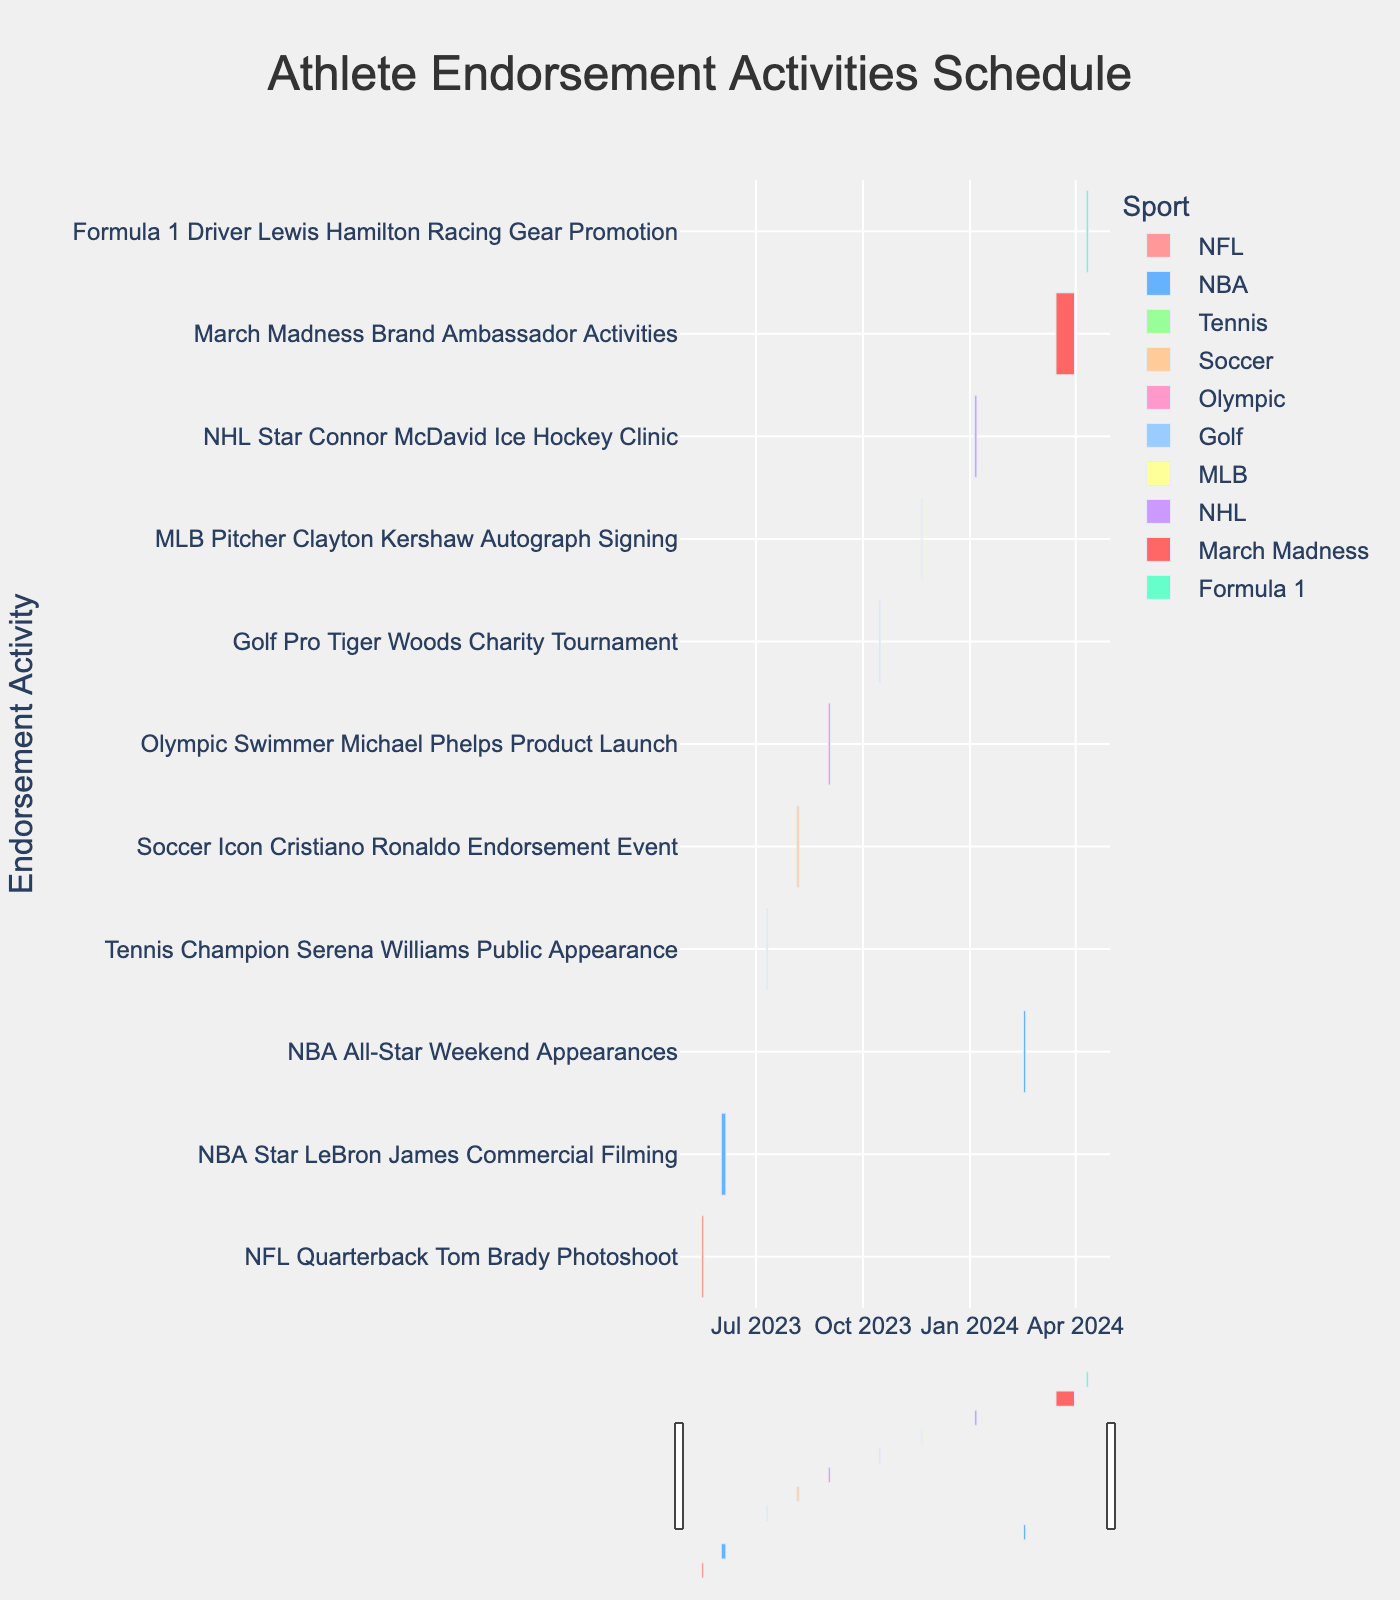Which athlete has the earliest scheduled endorsement activity? The NFL Quarterback Tom Brady's Photoshoot is scheduled from May 15, 2023, to May 17, 2023, which is the earliest date range on the Gantt Chart.
Answer: Tom Brady What are the dates for the March Madness Brand Ambassador Activities? By looking at the Gantt Chart, the March Madness Brand Ambassador Activities are scheduled from March 15, 2024, to March 31, 2024.
Answer: March 15, 2024, to March 31, 2024 Which event occurs right after the Soccer Icon Cristiano Ronaldo Endorsement Event? Cristiano Ronaldo's event ends on August 7, 2023. The next event, which starts after this, is the Olympic Swimmer Michael Phelps Product Launch from September 1, 2023, to September 3, 2023.
Answer: Michael Phelps Product Launch How many days in total does the Formula 1 Driver Lewis Hamilton Racing Gear Promotion last? The event starts on April 10, 2024, and ends on April 12, 2024. The duration is calculated as (April 12 - April 10) + 1. Therefore, it lasts for 3 days.
Answer: 3 days What is the total number of endorsement activities scheduled during the 2023 year? By counting the tasks that fall within the year 2023, we identify: Tom Brady Photoshoot, LeBron James Commercial Filming, Serena Williams Public Appearance, Cristiano Ronaldo Endorsement Event, Michael Phelps Product Launch, Tiger Woods Charity Tournament, and Clayton Kershaw Autograph Signing. This totals to 7 activities.
Answer: 7 activities Which sport has the most endorsement activities scheduled? By color coding and counting the tasks, NBA has two events: LeBron James Commercial Filming and NBA All-Star Weekend Appearances. Other sports have only one activity each.
Answer: NBA Between which two athletes' endorsement activities is there the longest gap? The longest gap between activities can be calculated as the time between Clayton Kershaw’s Autograph Signing ends on November 21, 2023, and Connor McDavid’s Ice Hockey Clinic starts on January 5, 2024, which is the gap of (January 5, 2024 - November 21, 2023). This results in a gap of 45 days.
Answer: Clayton Kershaw and Connor McDavid Are there any events scheduled on overlapping dates? By checking against the dates, no two events have any overlapping date ranges; each event is scheduled on distinct dates.
Answer: No Which event has the shortest duration, and how long is it? The shortest duration is the Public Appearance by Tennis Champion Serena Williams, scheduled from July 10, 2023, to July 11, 2023, lasting just 2 days.
Answer: Serena Williams Public Appearance, 2 days 